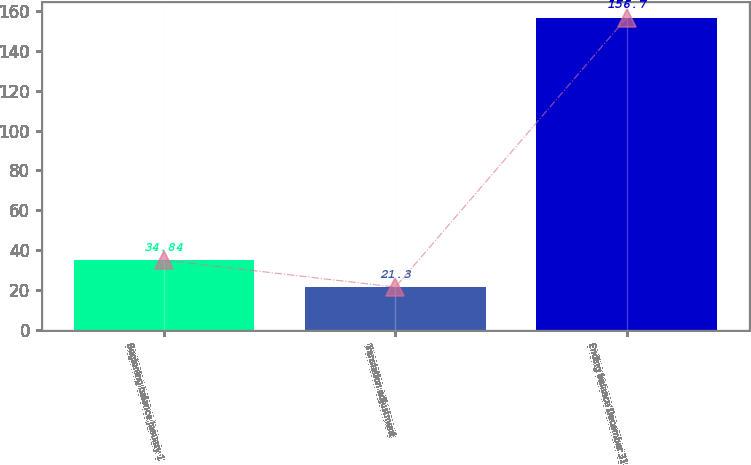Convert chart. <chart><loc_0><loc_0><loc_500><loc_500><bar_chart><fcel>Beginning balance January 1<fcel>Translation adjustment<fcel>Ending balance December 31<nl><fcel>34.84<fcel>21.3<fcel>156.7<nl></chart> 